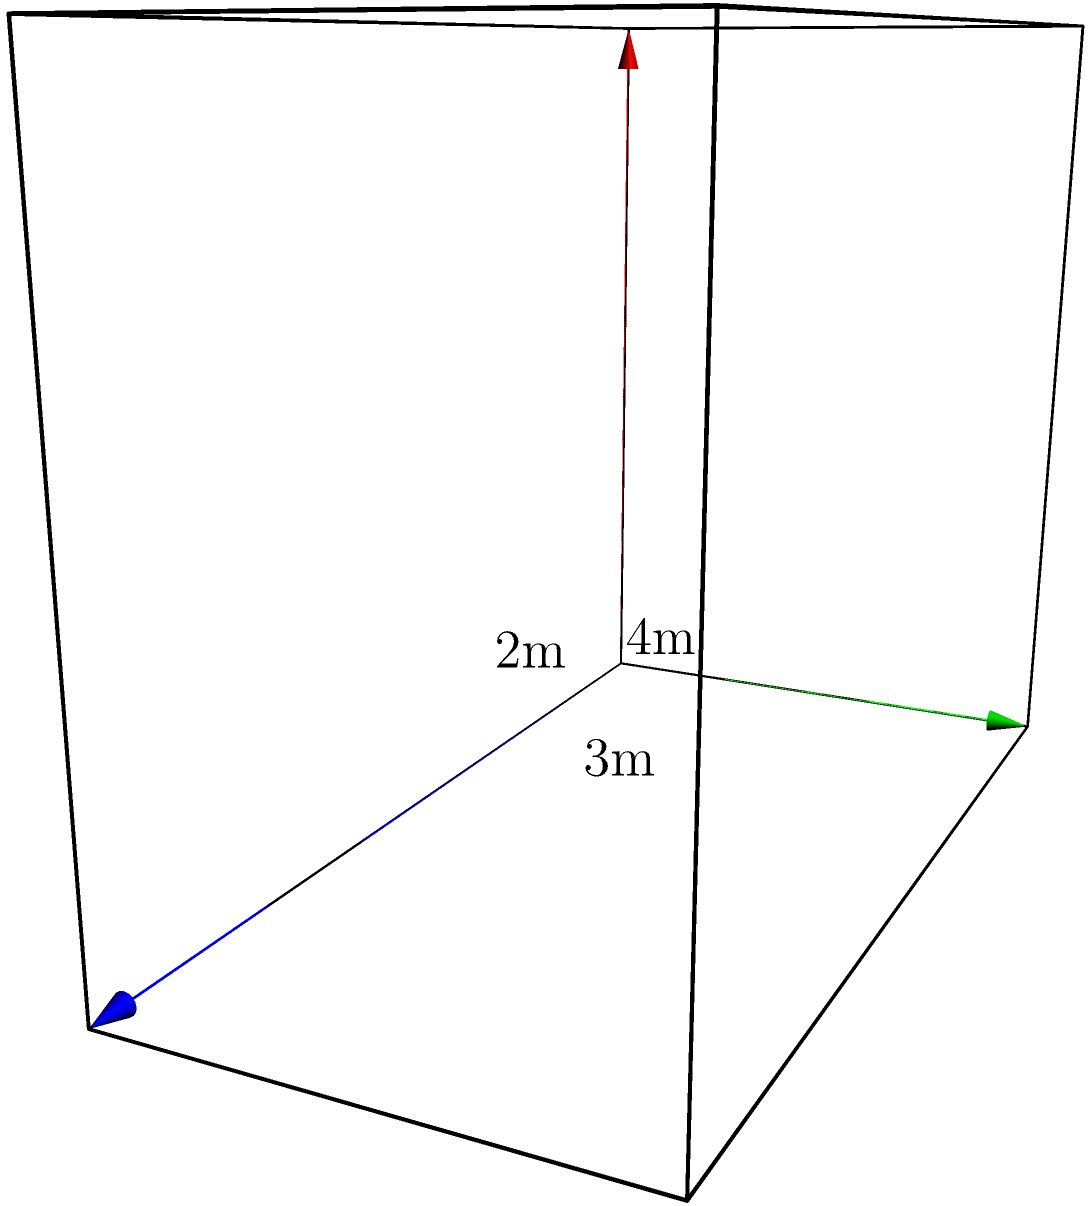A new battery storage unit for a solar energy system has been designed in the shape of a rectangular prism. The dimensions of the unit are 4 meters in length, 2 meters in width, and 3 meters in height. To ensure proper heat dissipation, the entire surface of the unit needs to be covered with a special coating. Calculate the total surface area of the battery storage unit that needs to be coated. To find the surface area of a rectangular prism, we need to calculate the area of all six faces and sum them up. Let's break it down step-by-step:

1. Identify the dimensions:
   Length (l) = 4 m
   Width (w) = 2 m
   Height (h) = 3 m

2. Calculate the area of the top and bottom faces:
   Area of top/bottom = l × w = 4 m × 2 m = 8 m²
   Total area of top and bottom = 2 × 8 m² = 16 m²

3. Calculate the area of the front and back faces:
   Area of front/back = l × h = 4 m × 3 m = 12 m²
   Total area of front and back = 2 × 12 m² = 24 m²

4. Calculate the area of the left and right faces:
   Area of left/right = w × h = 2 m × 3 m = 6 m²
   Total area of left and right = 2 × 6 m² = 12 m²

5. Sum up all the areas to get the total surface area:
   Total surface area = 16 m² + 24 m² + 12 m² = 52 m²

Therefore, the total surface area of the battery storage unit that needs to be coated is 52 square meters.
Answer: 52 m² 